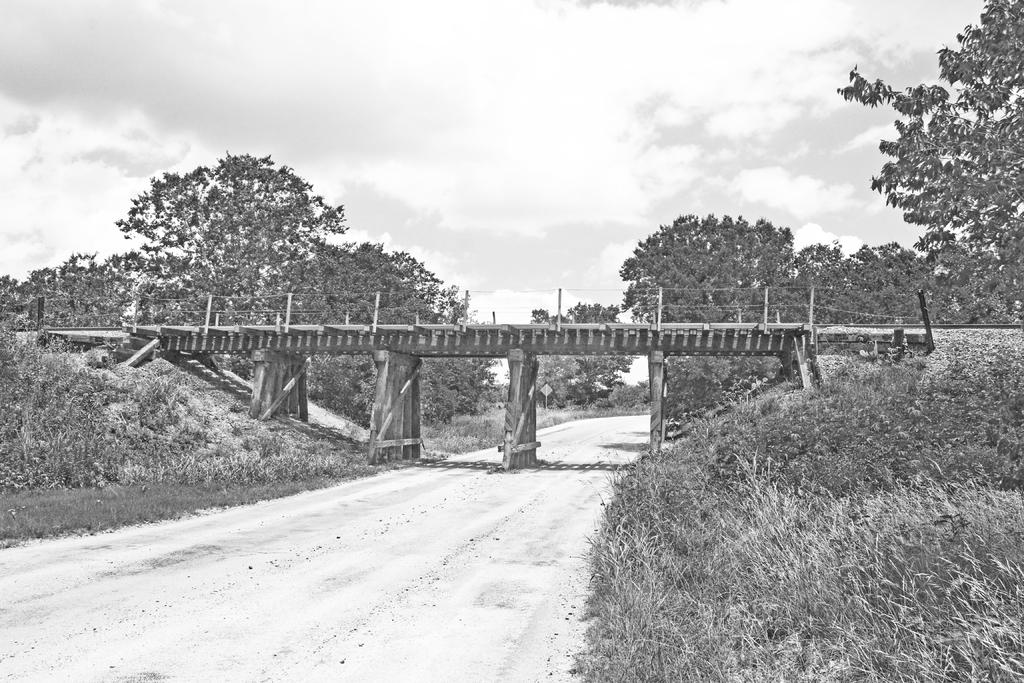What is the color scheme of the image? The image is in black and white. What can be seen in the foreground of the image? There is a road in the foreground of the image. What type of vegetation is present on either side of the road? There is grass on either side of the road. What structure is located in the middle of the image? There is a bridge in the middle of the image. What is visible in the background of the image? There are trees and the sky in the background of the image, but there are no references to a mind, wish, or word in the image. What word is written on the bridge in the image? There is no word written on the bridge in the image; it is a structure for vehicles and pedestrians to cross over. 